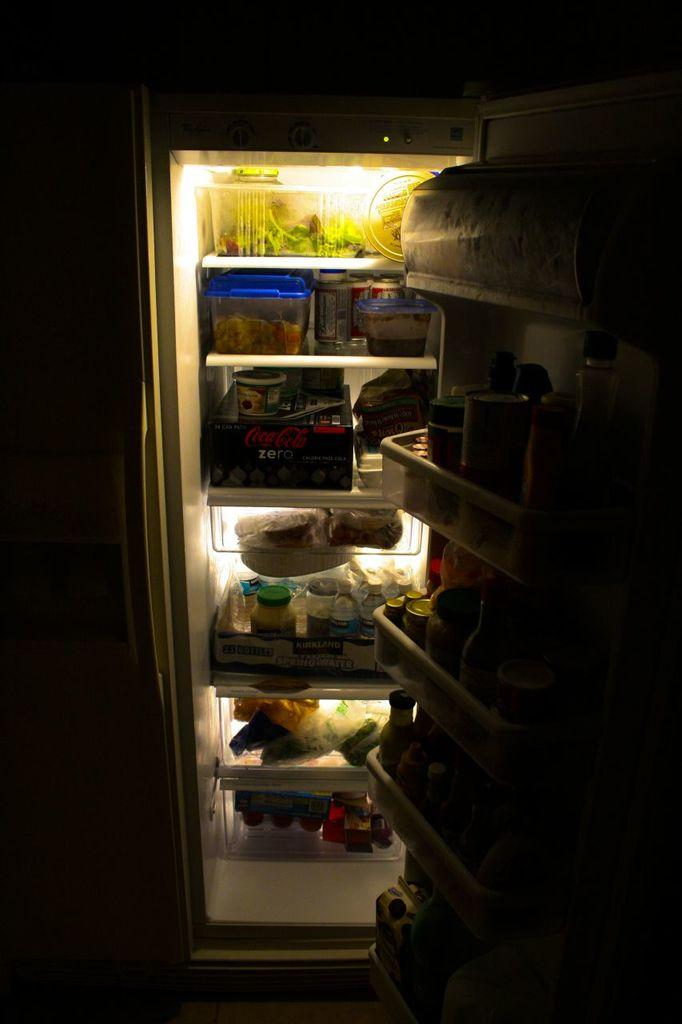<image>
Summarize the visual content of the image. The inside of a fridge with food and Coke Zero. 